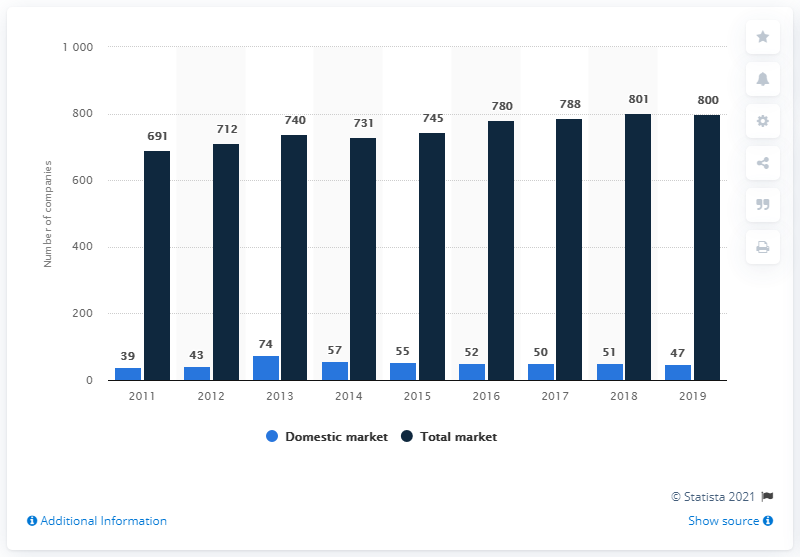Draw attention to some important aspects in this diagram. At the end of 2019, there were 47 companies present on the Finnish domestic insurance market. At the end of 2019, there were approximately 800 companies present on the Finnish domestic insurance market. 